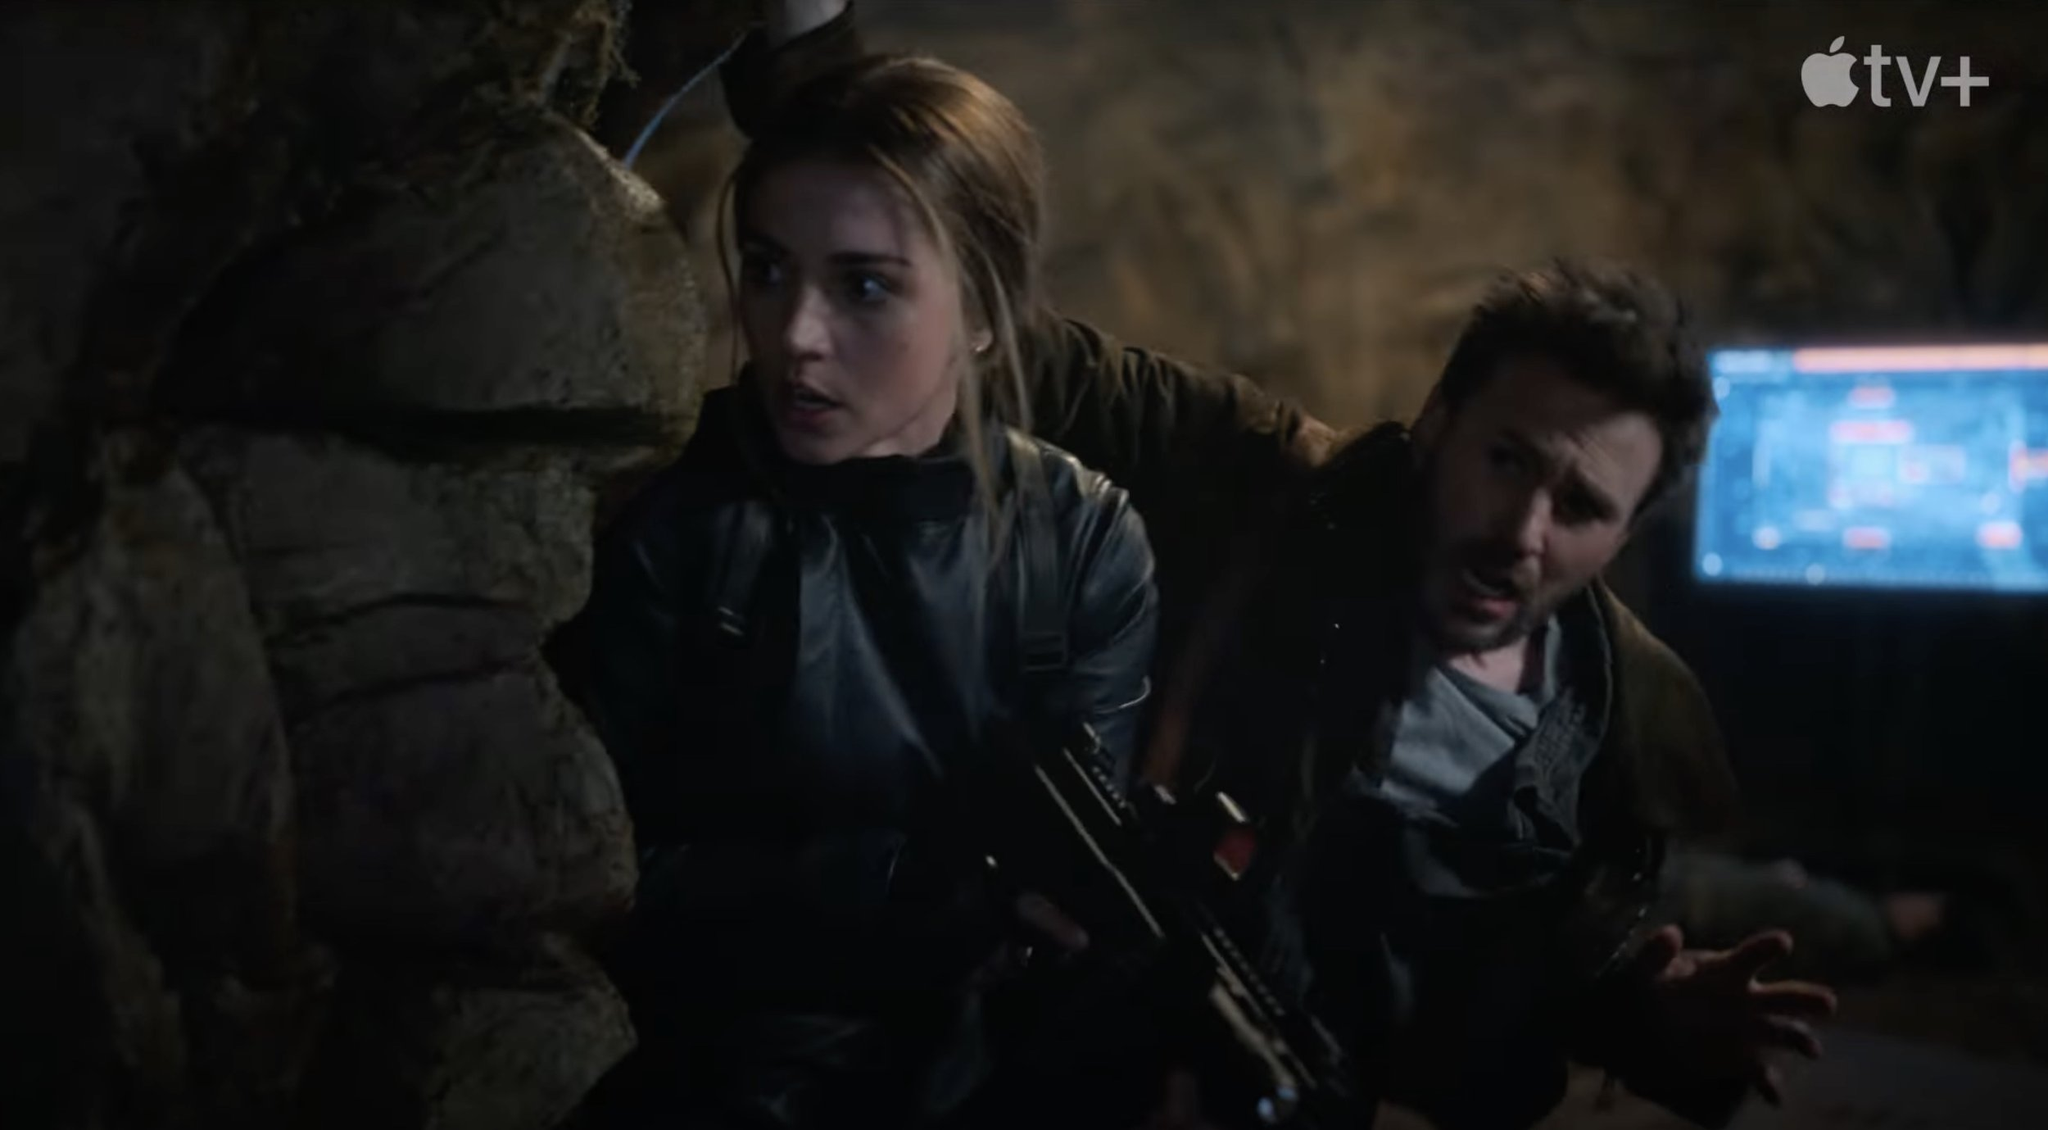What's happening in the scene? In this gripping scene from the movie or TV series, the characters are in a tense and dangerous situation. The setting resembles a dimly lit cave or underground hideout, which adds to the overall suspense. The female character on the left, dressed in a dark, tactical outfit, is alert and holding a firearm, ready for any threat. The male character on the right also appears tense, holding a gun while crouching and peering into the distance. The faint light illuminates their faces, highlighting the seriousness of the moment. The computer screen in the background suggests a technological aspect to the situation, perhaps indicating a high-stakes mission involving data or counter-surveillance. 